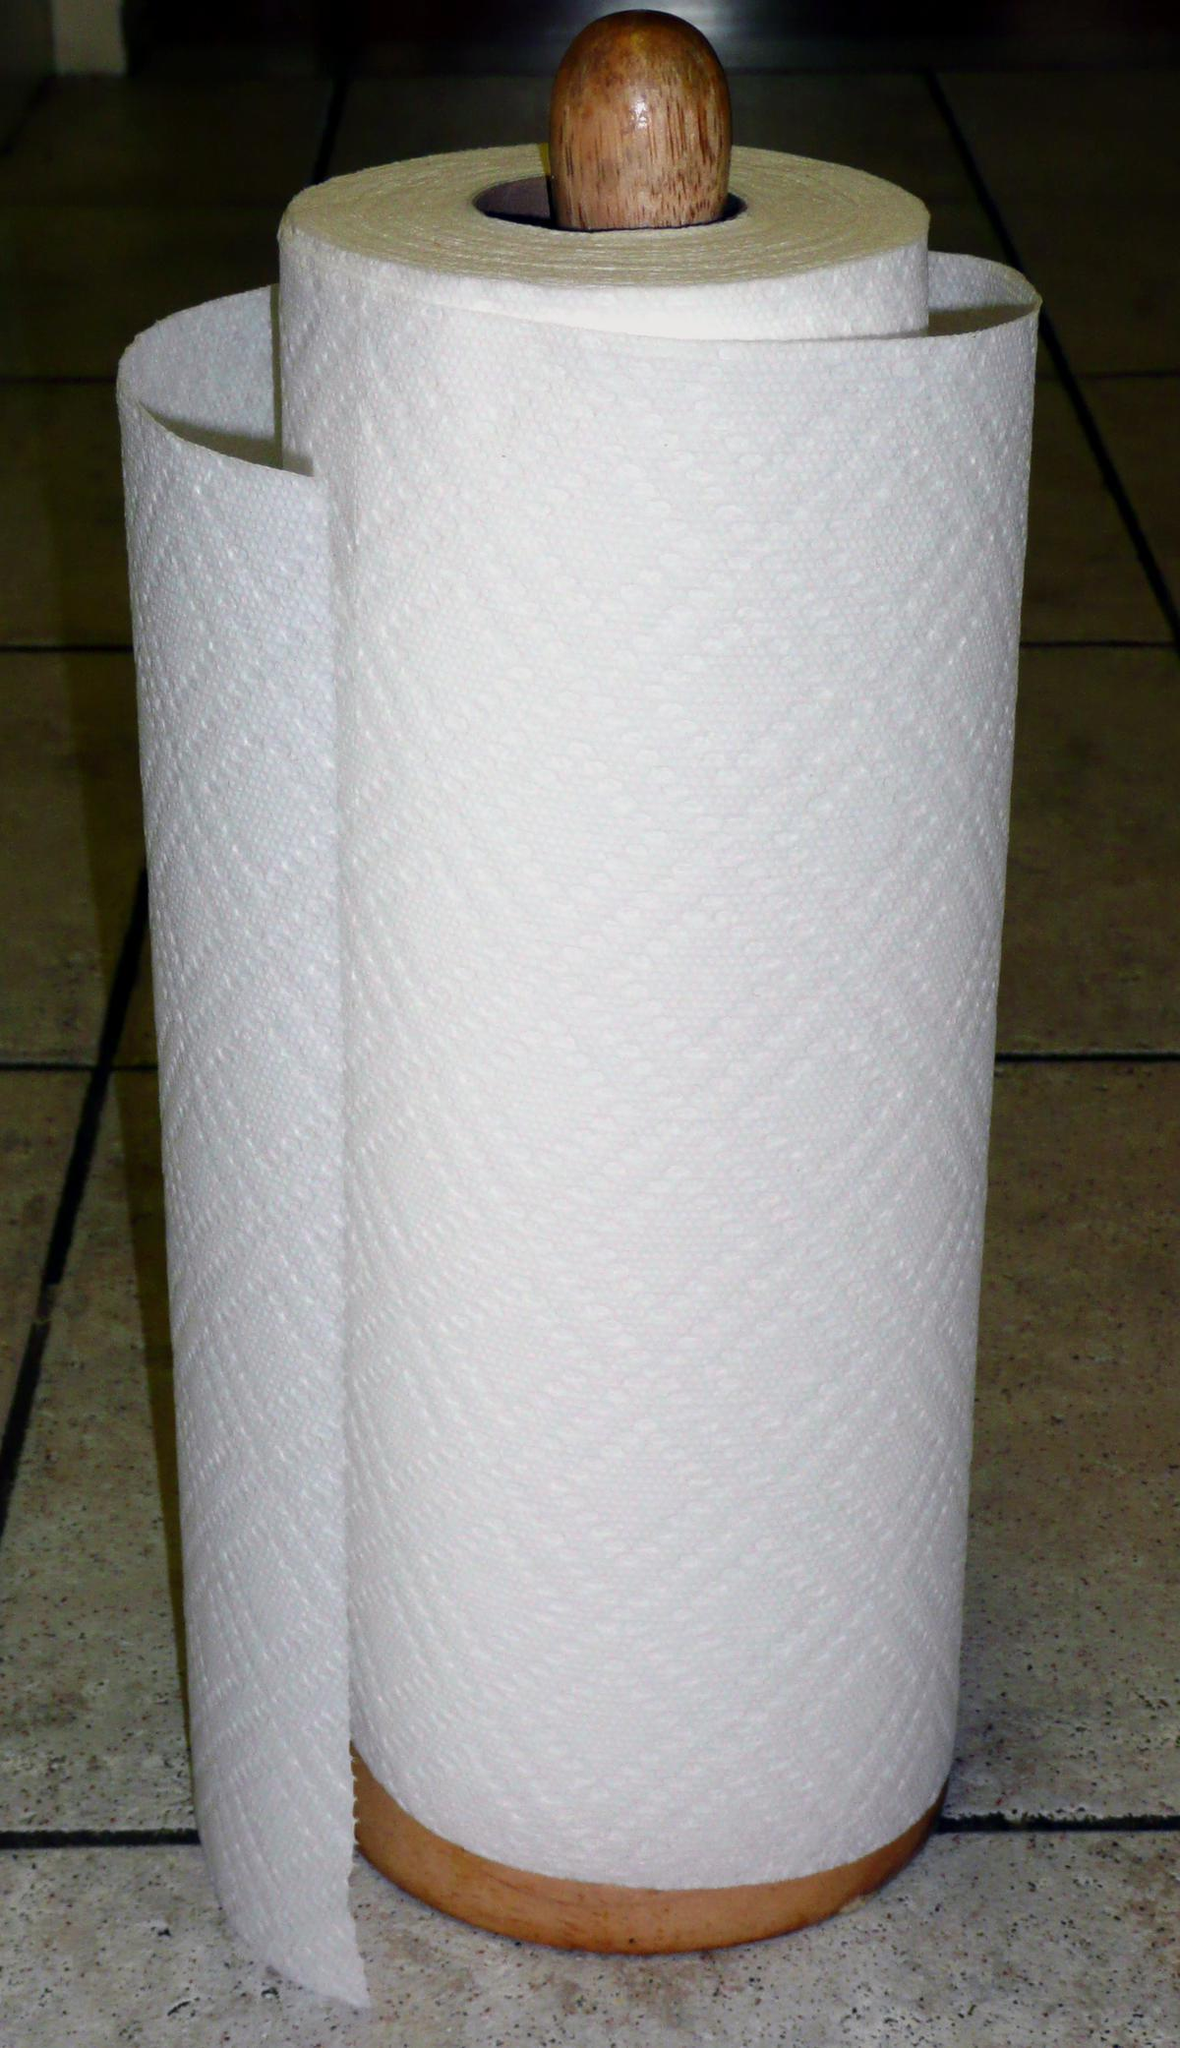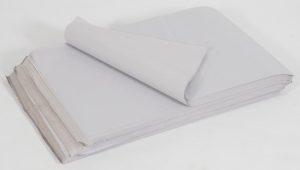The first image is the image on the left, the second image is the image on the right. Examine the images to the left and right. Is the description "An image shows only flat, folded paper towels." accurate? Answer yes or no. Yes. The first image is the image on the left, the second image is the image on the right. Considering the images on both sides, is "All paper towels are white and on rolls." valid? Answer yes or no. No. 